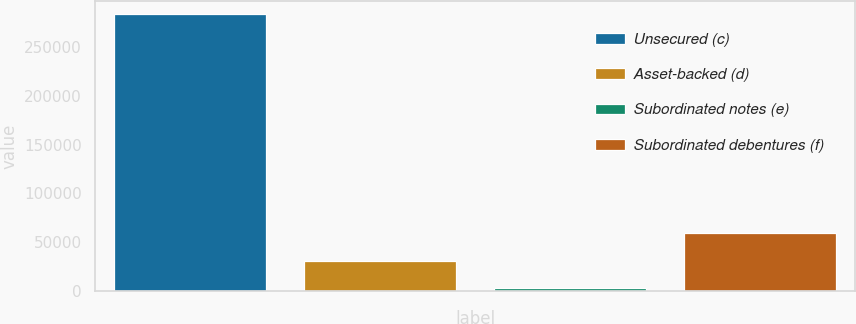Convert chart to OTSL. <chart><loc_0><loc_0><loc_500><loc_500><bar_chart><fcel>Unsecured (c)<fcel>Asset-backed (d)<fcel>Subordinated notes (e)<fcel>Subordinated debentures (f)<nl><fcel>283097<fcel>31291.4<fcel>3313<fcel>59269.8<nl></chart> 